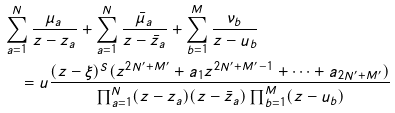<formula> <loc_0><loc_0><loc_500><loc_500>& \sum _ { a = 1 } ^ { N } \frac { \mu _ { a } } { z - z _ { a } } + \sum _ { a = 1 } ^ { N } \frac { \bar { \mu } _ { a } } { z - \bar { z } _ { a } } + \sum _ { b = 1 } ^ { M } \frac { \nu _ { b } } { z - u _ { b } } \\ & \quad = u \frac { ( z - \xi ) ^ { S } ( z ^ { 2 N ^ { \prime } + M ^ { \prime } } + a _ { 1 } z ^ { 2 N ^ { \prime } + M ^ { \prime } - 1 } + \cdots + a _ { 2 N ^ { \prime } + M ^ { \prime } } ) } { \prod _ { a = 1 } ^ { N } ( z - z _ { a } ) ( z - \bar { z } _ { a } ) \prod _ { b = 1 } ^ { M } ( z - u _ { b } ) }</formula> 